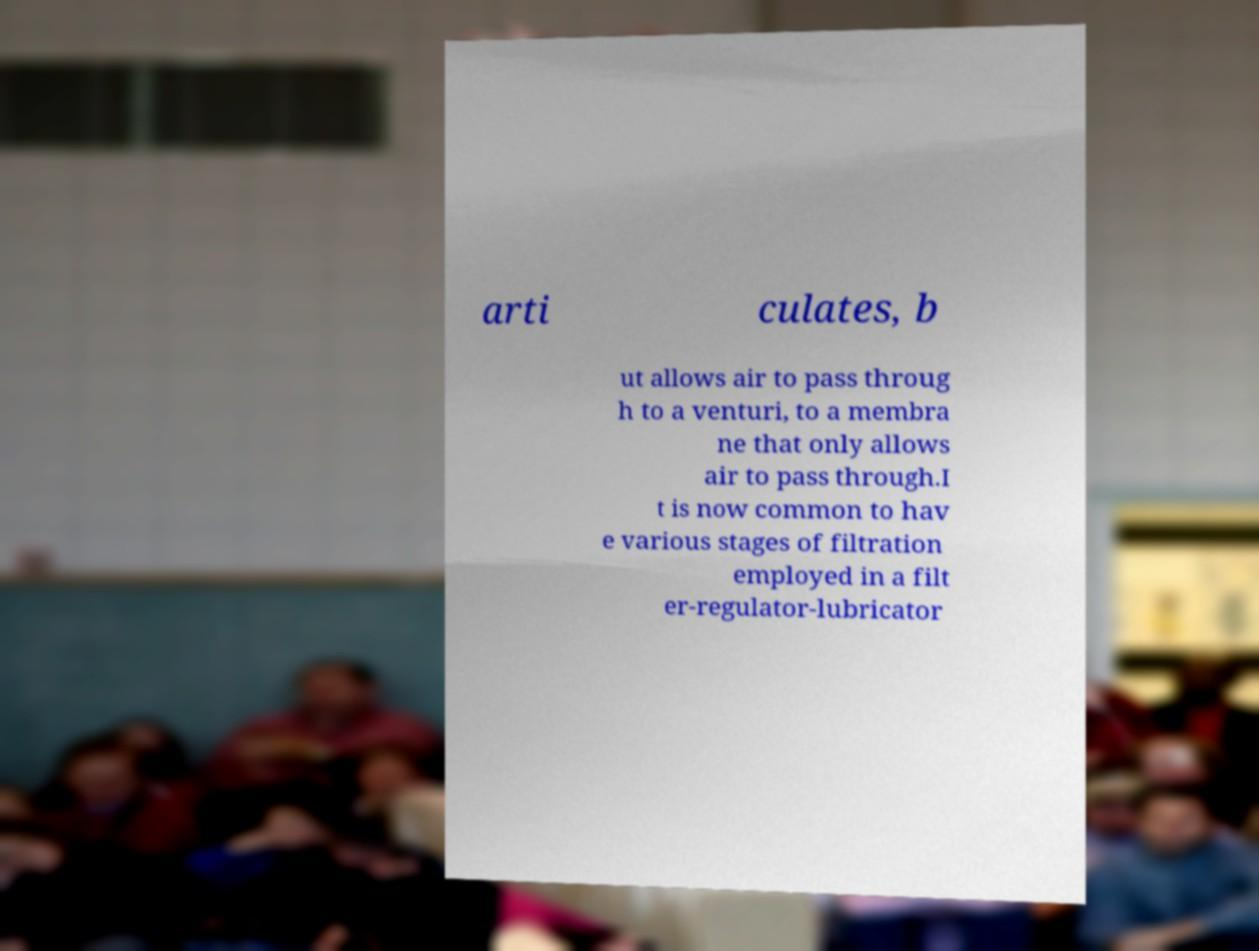Could you extract and type out the text from this image? arti culates, b ut allows air to pass throug h to a venturi, to a membra ne that only allows air to pass through.I t is now common to hav e various stages of filtration employed in a filt er-regulator-lubricator 